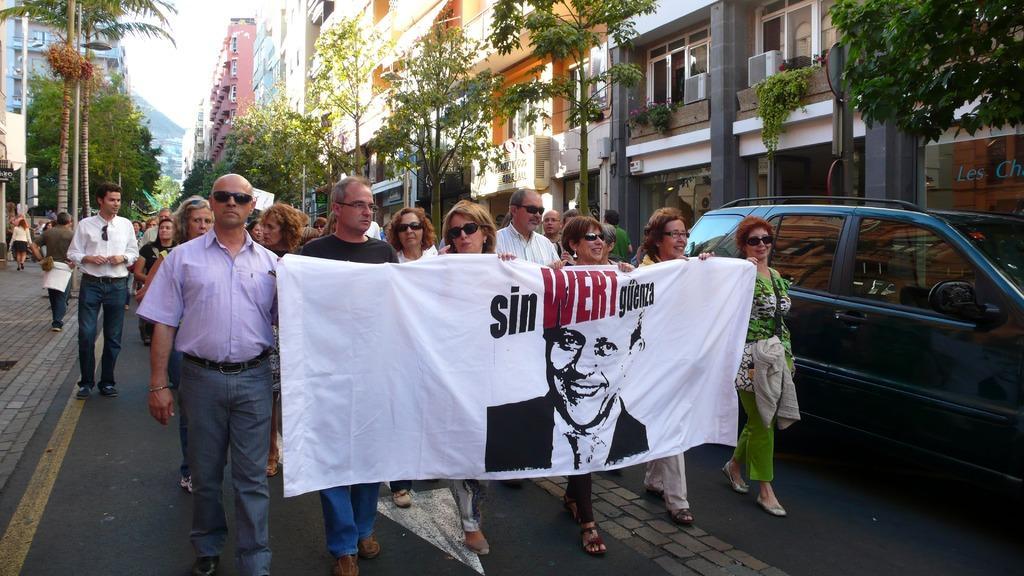Describe this image in one or two sentences. These people are walking and holding banner and we can see car on the road. Background we can see buildings,trees and sky. 